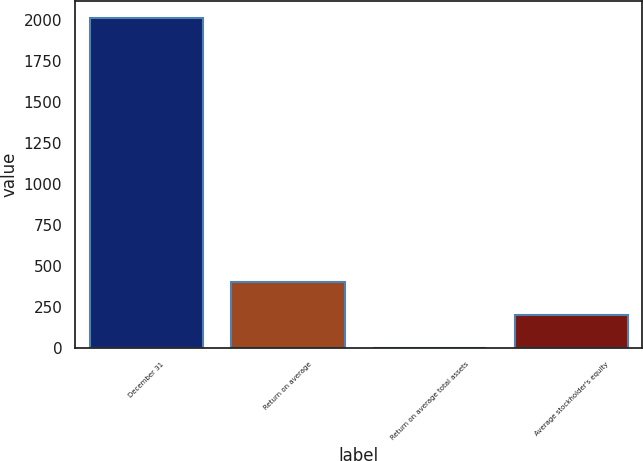Convert chart to OTSL. <chart><loc_0><loc_0><loc_500><loc_500><bar_chart><fcel>December 31<fcel>Return on average<fcel>Return on average total assets<fcel>Average stockholder's equity<nl><fcel>2014<fcel>403.53<fcel>0.91<fcel>202.22<nl></chart> 